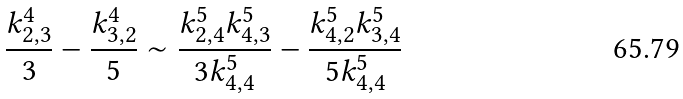<formula> <loc_0><loc_0><loc_500><loc_500>\frac { k _ { 2 , 3 } ^ { 4 } } { 3 } - \frac { k _ { 3 , 2 } ^ { 4 } } { 5 } \sim \frac { k _ { 2 , 4 } ^ { 5 } k _ { 4 , 3 } ^ { 5 } } { 3 k _ { 4 , 4 } ^ { 5 } } - \frac { k _ { 4 , 2 } ^ { 5 } k _ { 3 , 4 } ^ { 5 } } { 5 k _ { 4 , 4 } ^ { 5 } }</formula> 